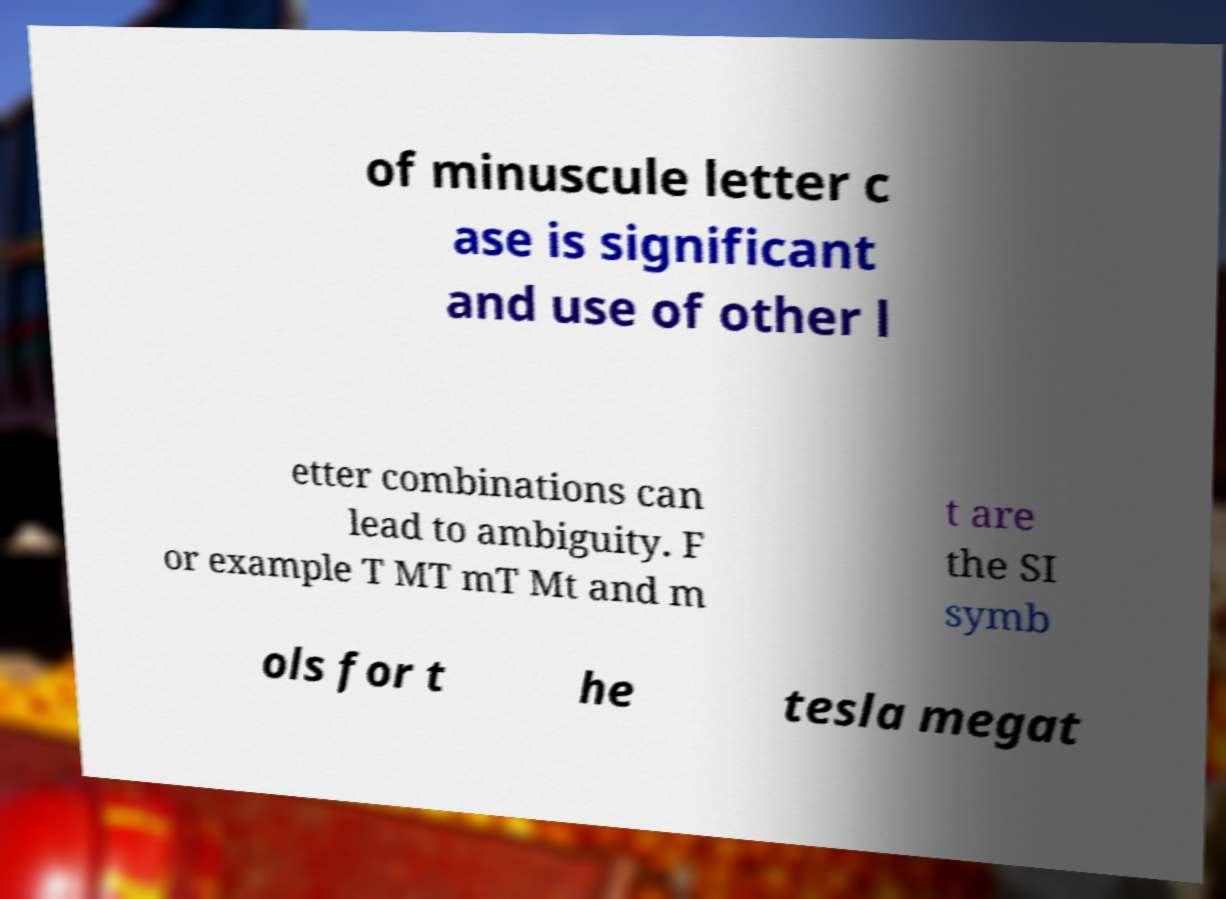Can you accurately transcribe the text from the provided image for me? of minuscule letter c ase is significant and use of other l etter combinations can lead to ambiguity. F or example T MT mT Mt and m t are the SI symb ols for t he tesla megat 